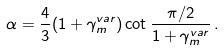<formula> <loc_0><loc_0><loc_500><loc_500>\alpha = { \frac { 4 } { 3 } } ( 1 + \gamma _ { m } ^ { v a r } ) \cot { \frac { \pi / 2 } { 1 + \gamma _ { m } ^ { v a r } } } \, .</formula> 